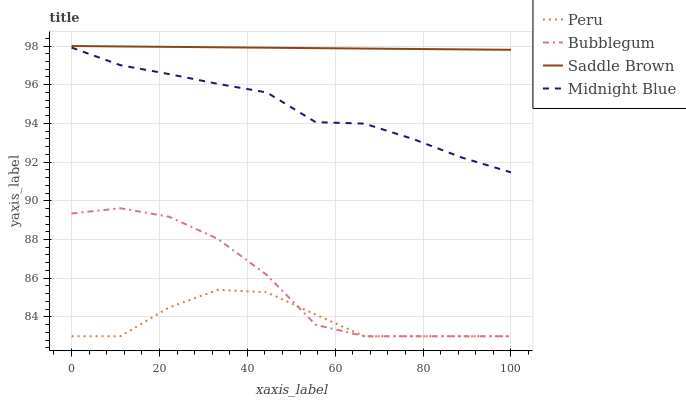Does Peru have the minimum area under the curve?
Answer yes or no. Yes. Does Saddle Brown have the maximum area under the curve?
Answer yes or no. Yes. Does Bubblegum have the minimum area under the curve?
Answer yes or no. No. Does Bubblegum have the maximum area under the curve?
Answer yes or no. No. Is Saddle Brown the smoothest?
Answer yes or no. Yes. Is Bubblegum the roughest?
Answer yes or no. Yes. Is Peru the smoothest?
Answer yes or no. No. Is Peru the roughest?
Answer yes or no. No. Does Bubblegum have the lowest value?
Answer yes or no. Yes. Does Saddle Brown have the lowest value?
Answer yes or no. No. Does Saddle Brown have the highest value?
Answer yes or no. Yes. Does Bubblegum have the highest value?
Answer yes or no. No. Is Peru less than Saddle Brown?
Answer yes or no. Yes. Is Saddle Brown greater than Peru?
Answer yes or no. Yes. Does Peru intersect Bubblegum?
Answer yes or no. Yes. Is Peru less than Bubblegum?
Answer yes or no. No. Is Peru greater than Bubblegum?
Answer yes or no. No. Does Peru intersect Saddle Brown?
Answer yes or no. No. 